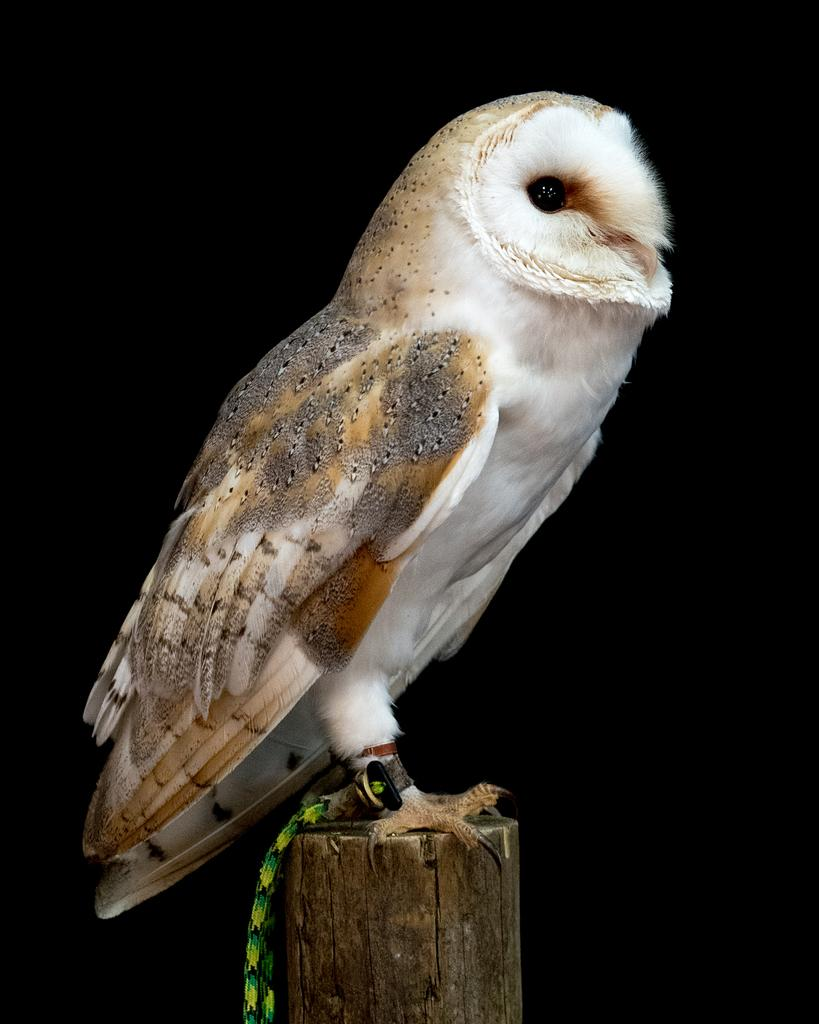What type of animal is in the image? There is a bird in the image. Where is the bird located? The bird is on a trunk. What color is the background of the image? The background of the image is black. What type of beef is being served on the bird's back in the image? There is no beef present in the image; it features a bird on a trunk with a black background. What direction is the bat flying in the image? There is no bat present in the image; it features a bird on a trunk with a black background. 